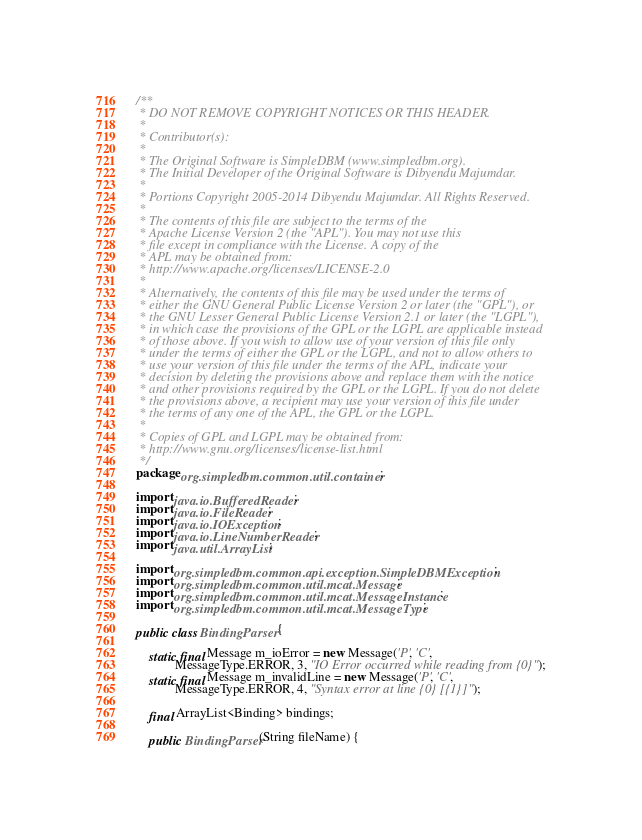Convert code to text. <code><loc_0><loc_0><loc_500><loc_500><_Java_>/**
 * DO NOT REMOVE COPYRIGHT NOTICES OR THIS HEADER.
 *
 * Contributor(s):
 *
 * The Original Software is SimpleDBM (www.simpledbm.org).
 * The Initial Developer of the Original Software is Dibyendu Majumdar.
 *
 * Portions Copyright 2005-2014 Dibyendu Majumdar. All Rights Reserved.
 *
 * The contents of this file are subject to the terms of the
 * Apache License Version 2 (the "APL"). You may not use this
 * file except in compliance with the License. A copy of the
 * APL may be obtained from:
 * http://www.apache.org/licenses/LICENSE-2.0
 *
 * Alternatively, the contents of this file may be used under the terms of
 * either the GNU General Public License Version 2 or later (the "GPL"), or
 * the GNU Lesser General Public License Version 2.1 or later (the "LGPL"),
 * in which case the provisions of the GPL or the LGPL are applicable instead
 * of those above. If you wish to allow use of your version of this file only
 * under the terms of either the GPL or the LGPL, and not to allow others to
 * use your version of this file under the terms of the APL, indicate your
 * decision by deleting the provisions above and replace them with the notice
 * and other provisions required by the GPL or the LGPL. If you do not delete
 * the provisions above, a recipient may use your version of this file under
 * the terms of any one of the APL, the GPL or the LGPL.
 *
 * Copies of GPL and LGPL may be obtained from:
 * http://www.gnu.org/licenses/license-list.html
 */
package org.simpledbm.common.util.container;

import java.io.BufferedReader;
import java.io.FileReader;
import java.io.IOException;
import java.io.LineNumberReader;
import java.util.ArrayList;

import org.simpledbm.common.api.exception.SimpleDBMException;
import org.simpledbm.common.util.mcat.Message;
import org.simpledbm.common.util.mcat.MessageInstance;
import org.simpledbm.common.util.mcat.MessageType;

public class BindingParser {

    static final Message m_ioError = new Message('P', 'C',
            MessageType.ERROR, 3, "IO Error occurred while reading from {0}");
    static final Message m_invalidLine = new Message('P', 'C',
            MessageType.ERROR, 4, "Syntax error at line {0} [{1}]");

    final ArrayList<Binding> bindings;

    public BindingParser(String fileName) {</code> 